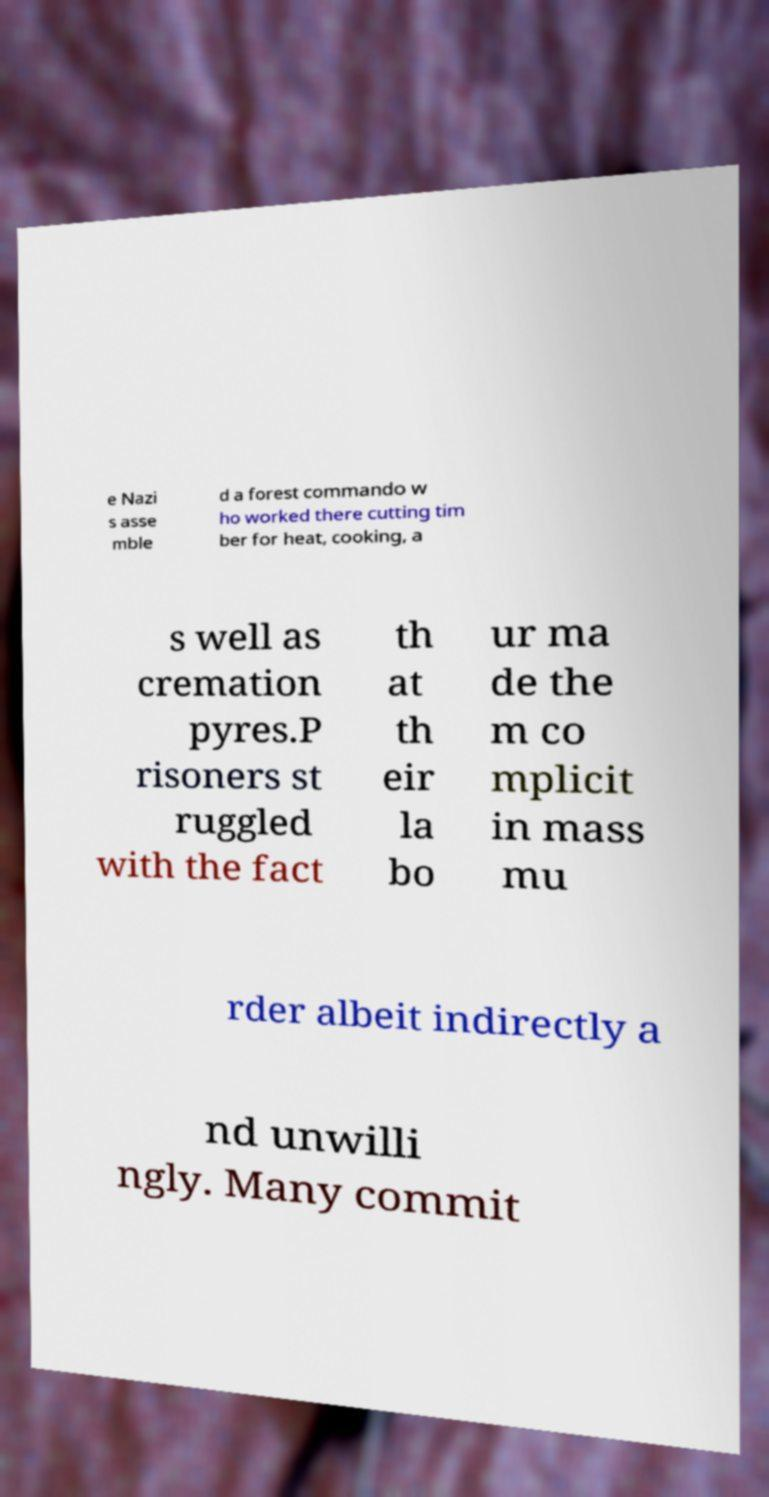What messages or text are displayed in this image? I need them in a readable, typed format. e Nazi s asse mble d a forest commando w ho worked there cutting tim ber for heat, cooking, a s well as cremation pyres.P risoners st ruggled with the fact th at th eir la bo ur ma de the m co mplicit in mass mu rder albeit indirectly a nd unwilli ngly. Many commit 